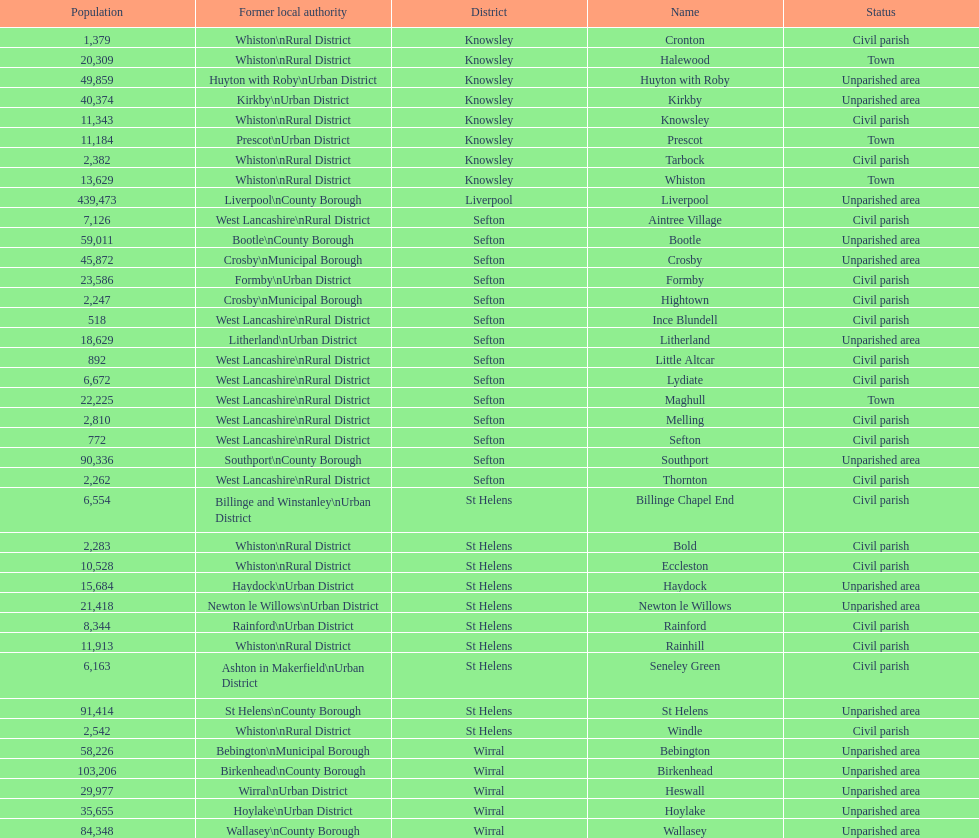What is the largest area in terms of population? Liverpool. 